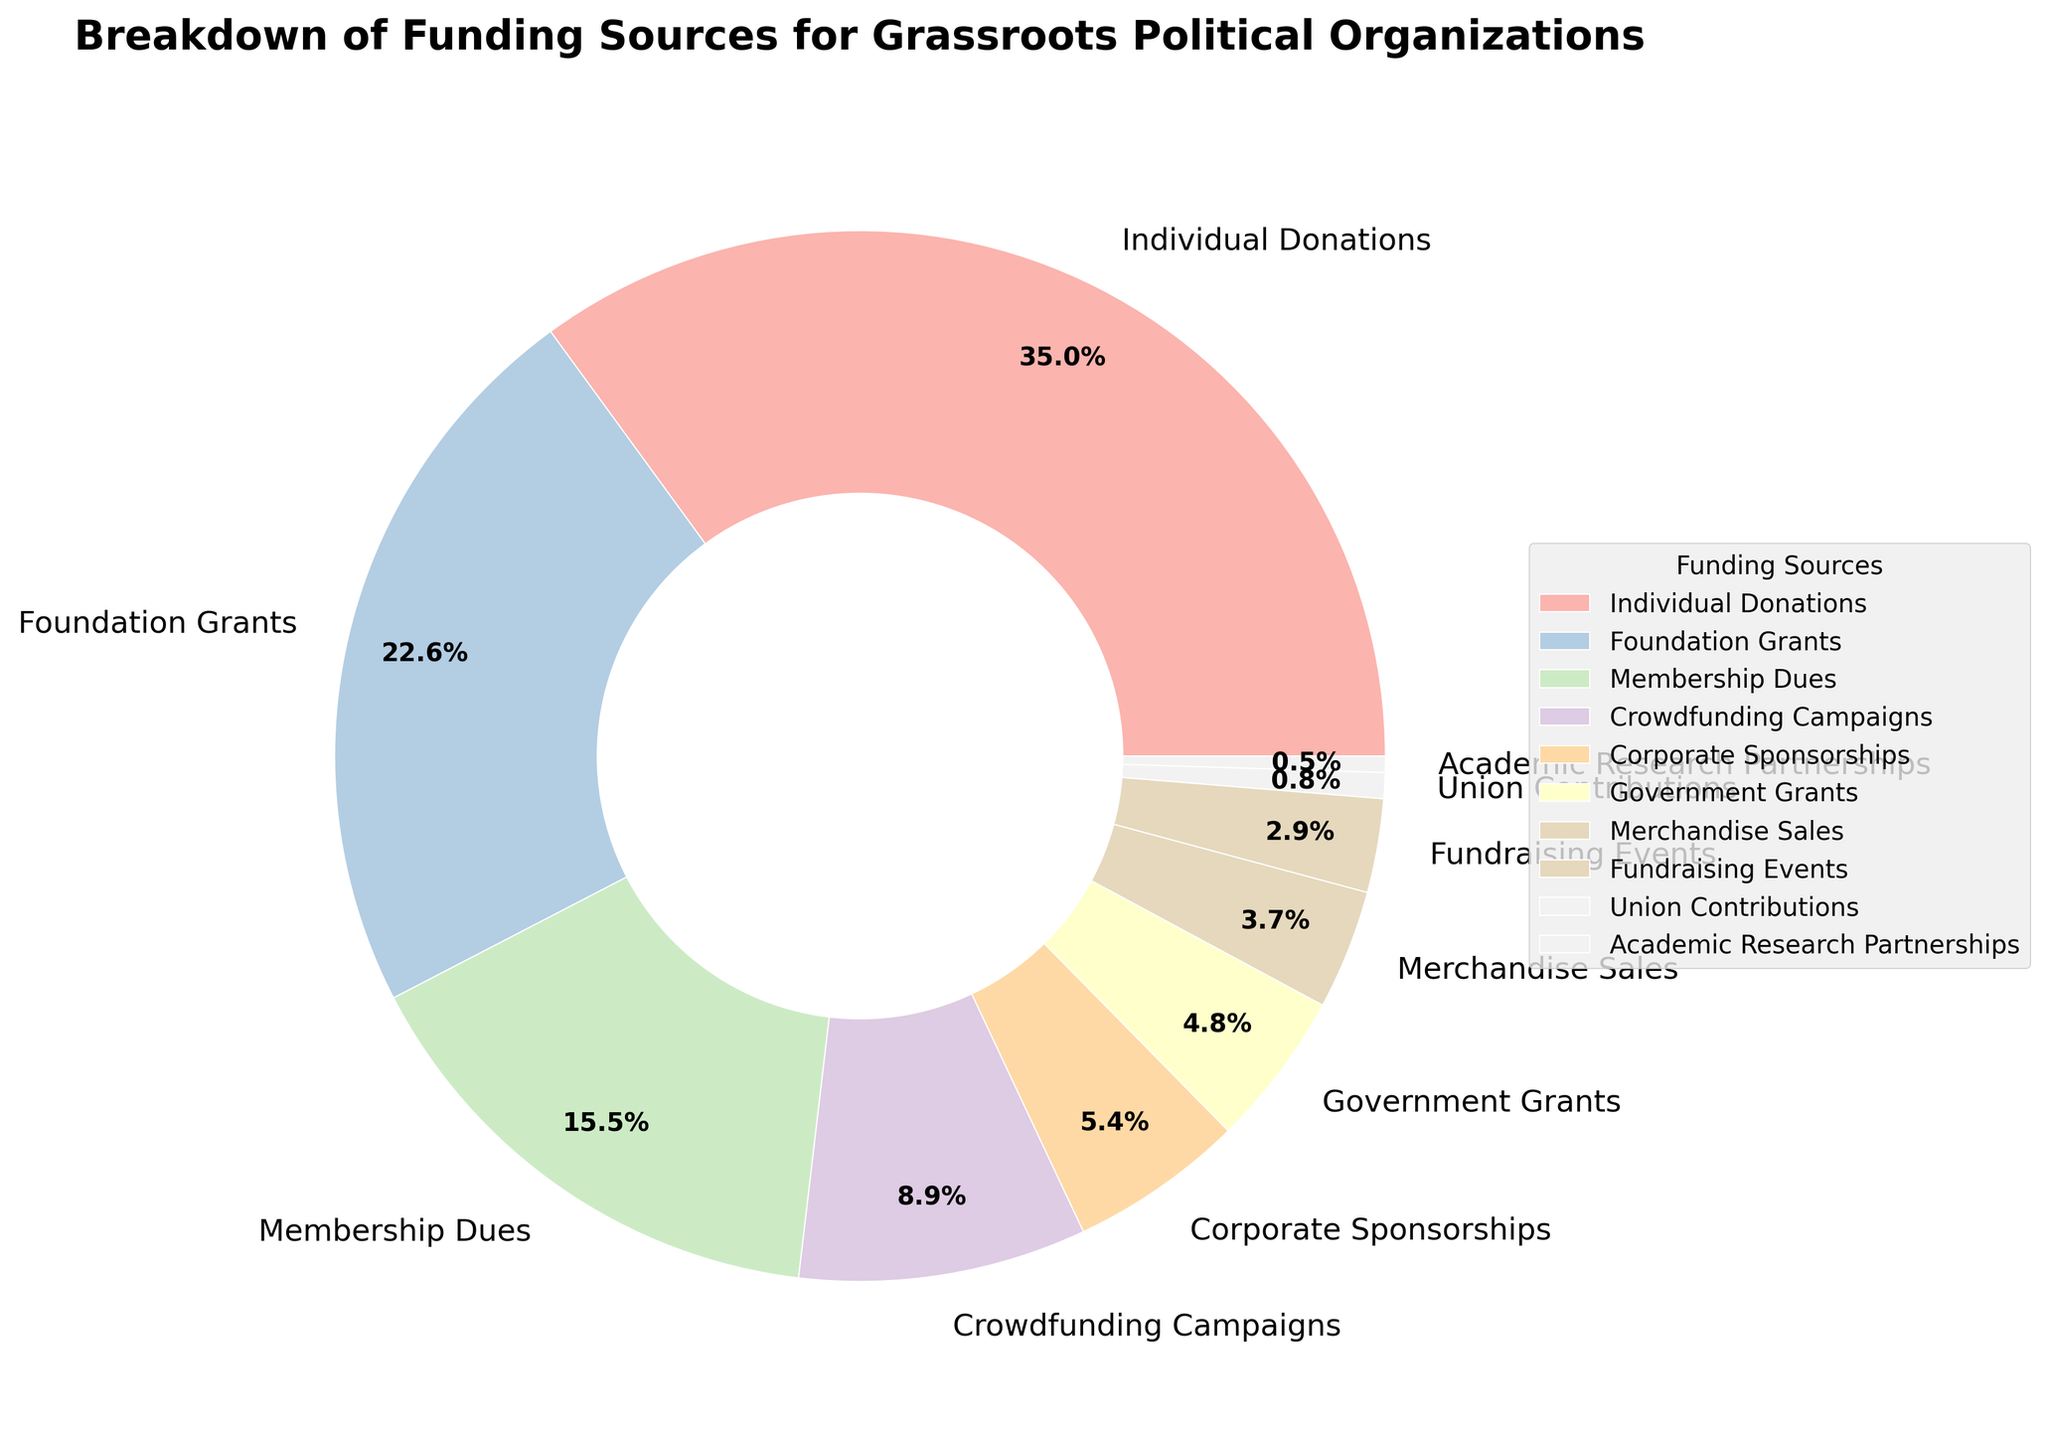Which funding source contributes the most to grassroots political organizations? The pie chart shows the contributions from various funding sources, and the one with the largest percentage visually represents the highest contribution. In this case, Individual Donations contribute the most, as indicated by the 35.2% slice.
Answer: Individual Donations How much more do Foundation Grants contribute compared to Government Grants? To find the difference, we subtract the percentage of Government Grants from Foundation Grants. Foundation Grants contribute 22.7%, and Government Grants contribute 4.8%. So, 22.7% - 4.8% = 17.9%.
Answer: 17.9% Which source has the smallest contribution to grassroots political organizations? The source with the smallest slice in the pie chart represents the smallest contribution. In this case, Academic Research Partnerships have the smallest contributions at 0.5%.
Answer: Academic Research Partnerships Combine the contributions from Crowdfunding Campaigns and Fundraising Events. What is the total percentage? Summing the contributions of Crowdfunding Campaigns (8.9%) and Fundraising Events (2.9%) gives 8.9% + 2.9% = 11.8%.
Answer: 11.8% How do Membership Dues compare to Merchandise Sales? To compare them, look at the individual percentages in the pie chart. Membership Dues contribute 15.6%, whereas Merchandise Sales contribute 3.7%. Membership Dues contribute more.
Answer: Membership Dues contribute more What is the total contribution percentage of Corporate Sponsorships, Government Grants, and Union Contributions combined? Add the percentages of Corporate Sponsorships (5.4%), Government Grants (4.8%), and Union Contributions (0.8%). So, 5.4% + 4.8% + 0.8% = 11%.
Answer: 11% What is the difference in contribution percentages between Foundation Grants and Membership Dues? Subtract the Membership Dues percentage from the Foundation Grants percentage. Foundation Grants contribute 22.7%, and Membership Dues contribute 15.6%. So, 22.7% - 15.6% = 7.1%.
Answer: 7.1% Compare the combined percentage contribution of the two smallest sources to the percentage contribution of Crowdfunding Campaigns. Which is larger? The two smallest sources are Union Contributions (0.8%) and Academic Research Partnerships (0.5%). Their combined contribution is 0.8% + 0.5% = 1.3%. Crowdfunding Campaigns contribute 8.9%, which is larger than 1.3%.
Answer: Crowdfunding Campaigns 